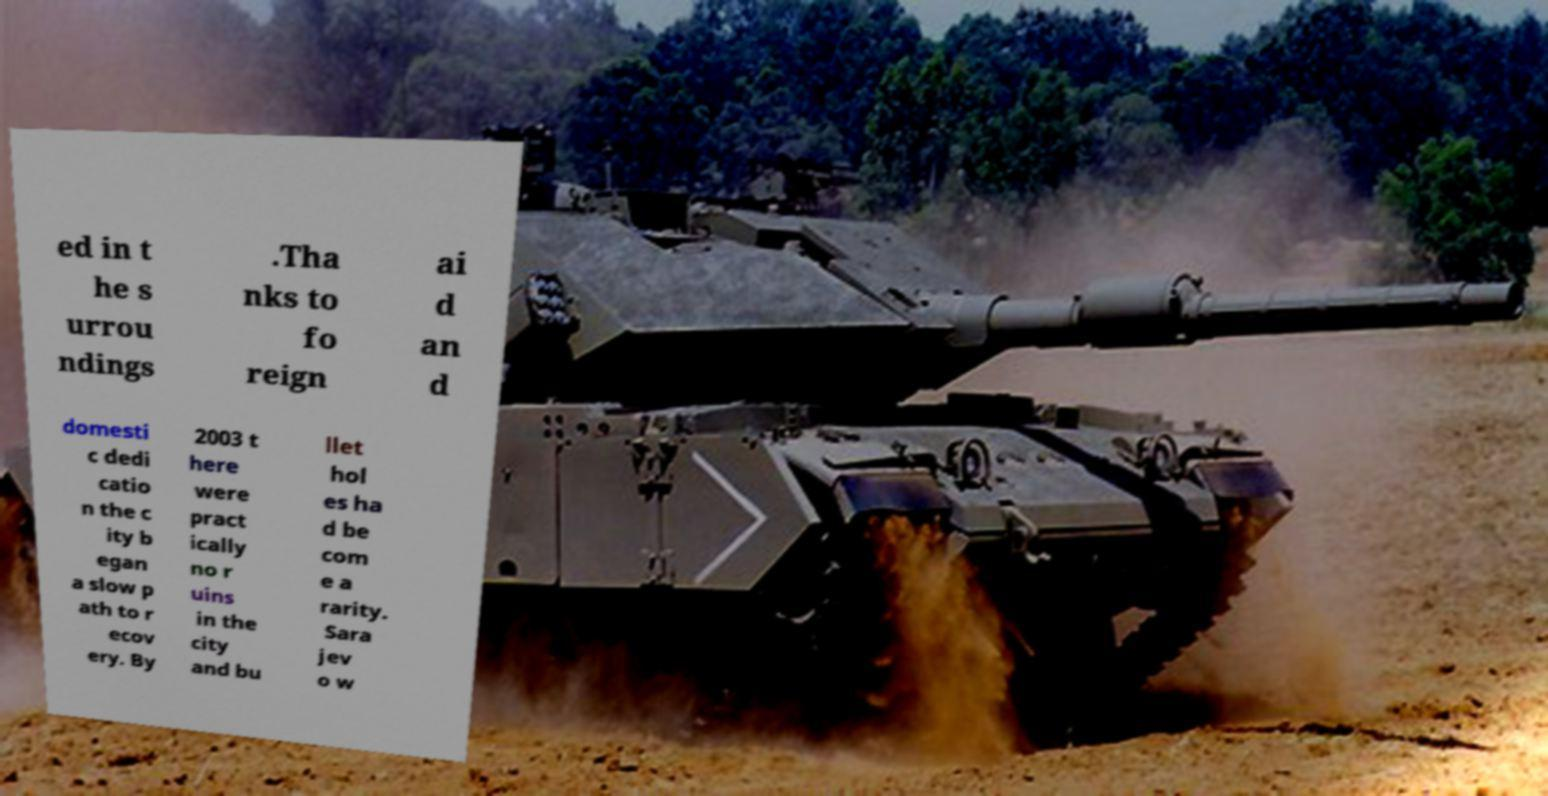For documentation purposes, I need the text within this image transcribed. Could you provide that? ed in t he s urrou ndings .Tha nks to fo reign ai d an d domesti c dedi catio n the c ity b egan a slow p ath to r ecov ery. By 2003 t here were pract ically no r uins in the city and bu llet hol es ha d be com e a rarity. Sara jev o w 